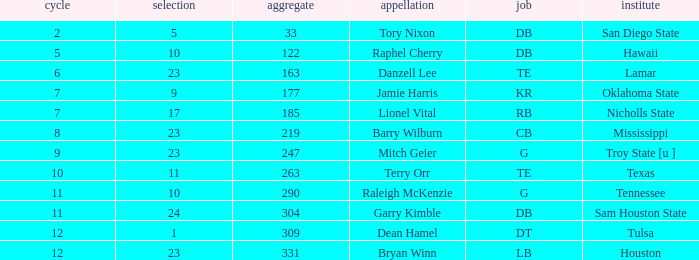Which Overall is the highest one that has a Name of raleigh mckenzie, and a Pick larger than 10? None. 